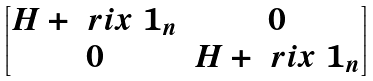<formula> <loc_0><loc_0><loc_500><loc_500>\begin{bmatrix} H + \ r i x \ 1 _ { n } & 0 \\ 0 & H + \ r i x \ 1 _ { n } \end{bmatrix}</formula> 